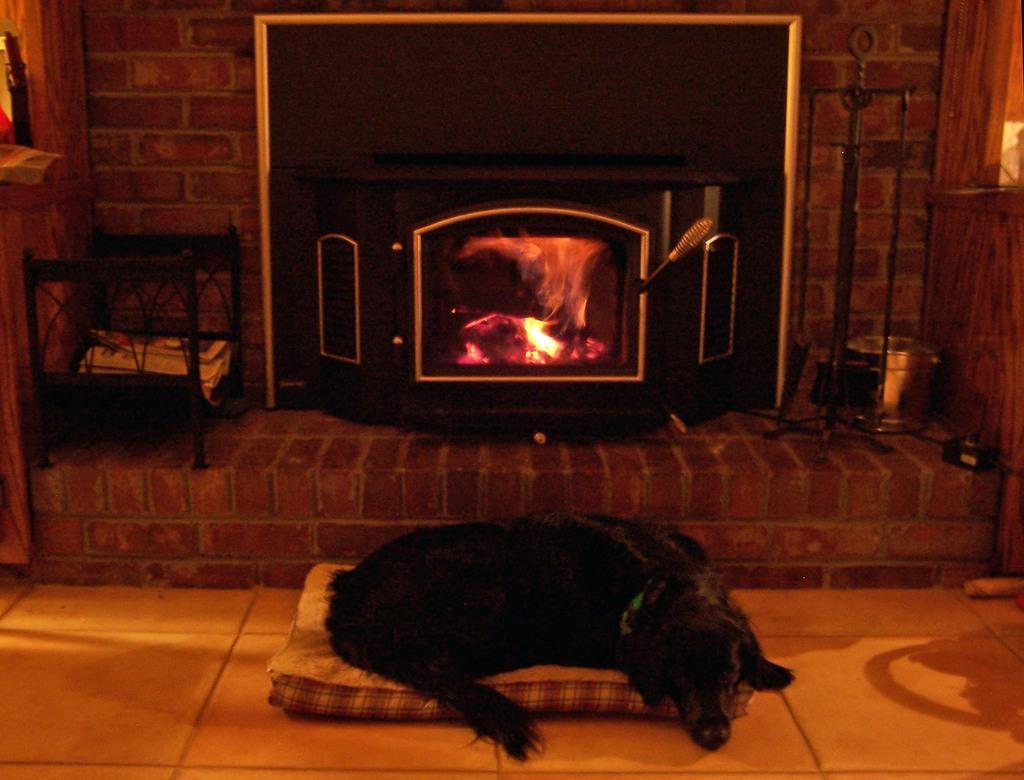Can you describe this image briefly? There is a dog on the bed. This is floor. Here we can see a wooden oven and there are papers. In the background we can see a wall. 